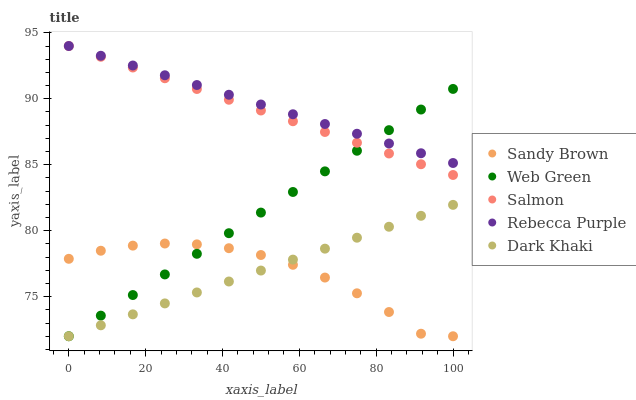Does Sandy Brown have the minimum area under the curve?
Answer yes or no. Yes. Does Rebecca Purple have the maximum area under the curve?
Answer yes or no. Yes. Does Salmon have the minimum area under the curve?
Answer yes or no. No. Does Salmon have the maximum area under the curve?
Answer yes or no. No. Is Web Green the smoothest?
Answer yes or no. Yes. Is Sandy Brown the roughest?
Answer yes or no. Yes. Is Salmon the smoothest?
Answer yes or no. No. Is Salmon the roughest?
Answer yes or no. No. Does Dark Khaki have the lowest value?
Answer yes or no. Yes. Does Salmon have the lowest value?
Answer yes or no. No. Does Rebecca Purple have the highest value?
Answer yes or no. Yes. Does Sandy Brown have the highest value?
Answer yes or no. No. Is Dark Khaki less than Salmon?
Answer yes or no. Yes. Is Rebecca Purple greater than Sandy Brown?
Answer yes or no. Yes. Does Rebecca Purple intersect Web Green?
Answer yes or no. Yes. Is Rebecca Purple less than Web Green?
Answer yes or no. No. Is Rebecca Purple greater than Web Green?
Answer yes or no. No. Does Dark Khaki intersect Salmon?
Answer yes or no. No. 